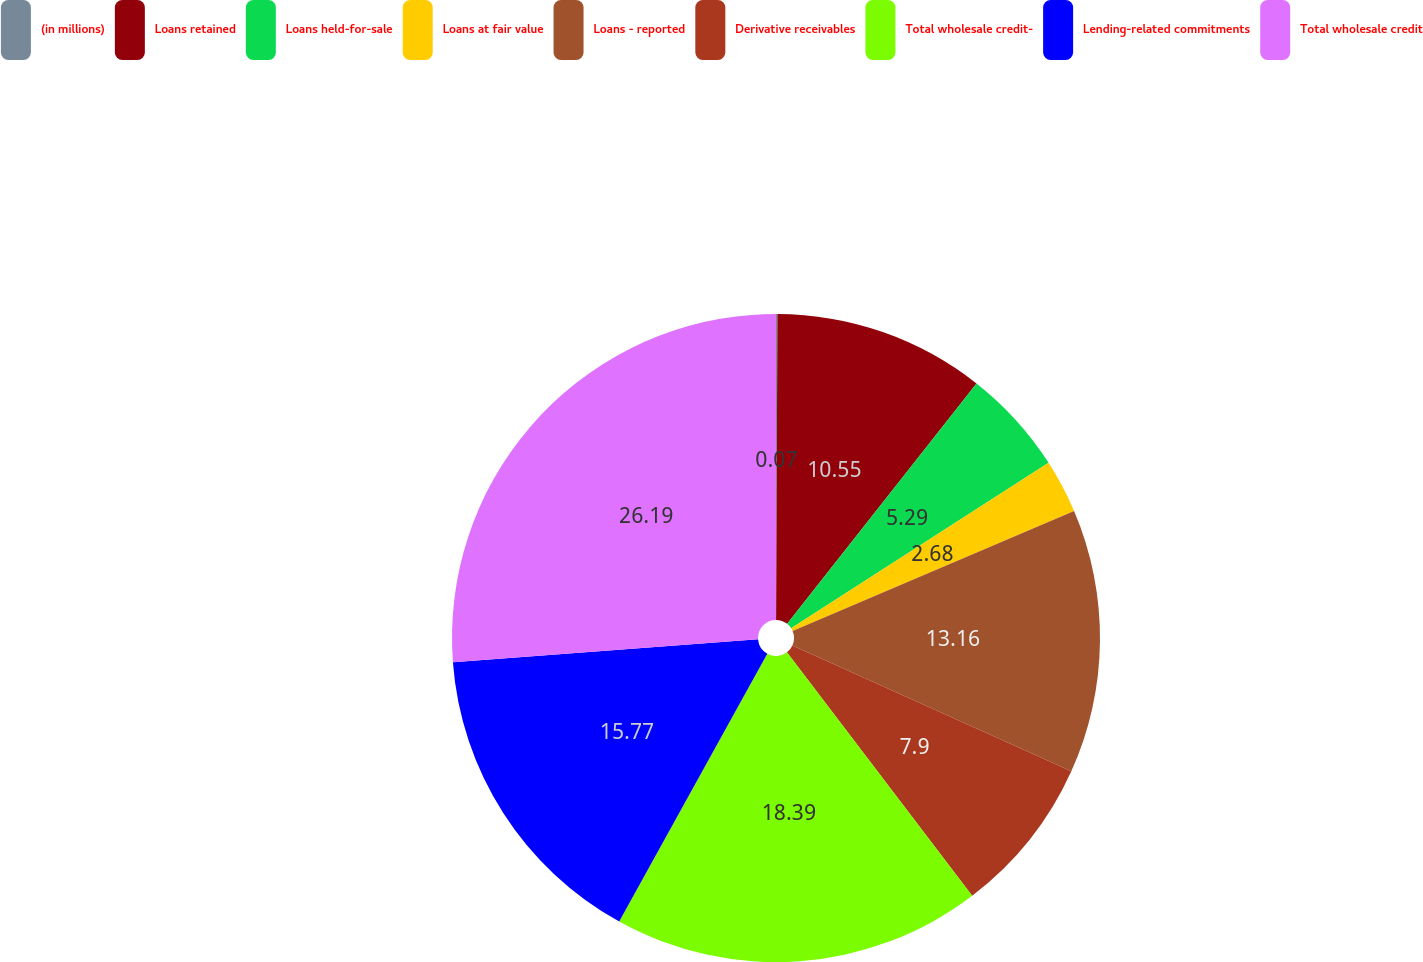<chart> <loc_0><loc_0><loc_500><loc_500><pie_chart><fcel>(in millions)<fcel>Loans retained<fcel>Loans held-for-sale<fcel>Loans at fair value<fcel>Loans - reported<fcel>Derivative receivables<fcel>Total wholesale credit-<fcel>Lending-related commitments<fcel>Total wholesale credit<nl><fcel>0.07%<fcel>10.55%<fcel>5.29%<fcel>2.68%<fcel>13.16%<fcel>7.9%<fcel>18.39%<fcel>15.77%<fcel>26.19%<nl></chart> 